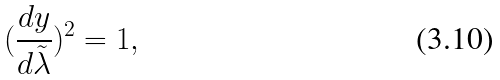<formula> <loc_0><loc_0><loc_500><loc_500>( \frac { d y } { d \tilde { \lambda } } ) ^ { 2 } = 1 ,</formula> 